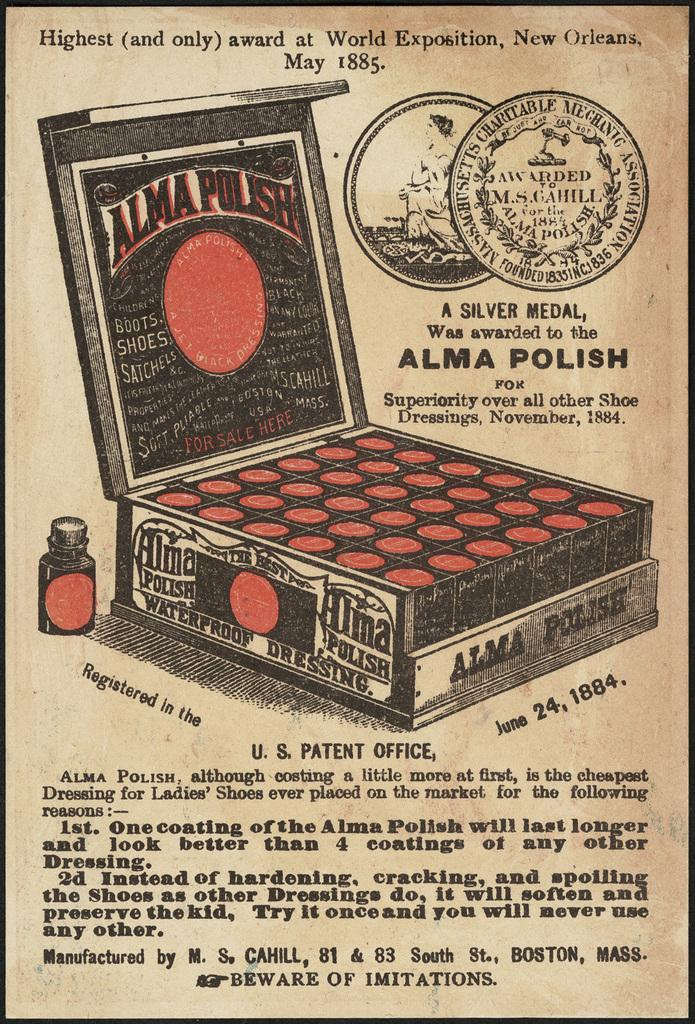<image>
Share a concise interpretation of the image provided. An old advertisement for Alma Polish proclaims that the product is superior. 